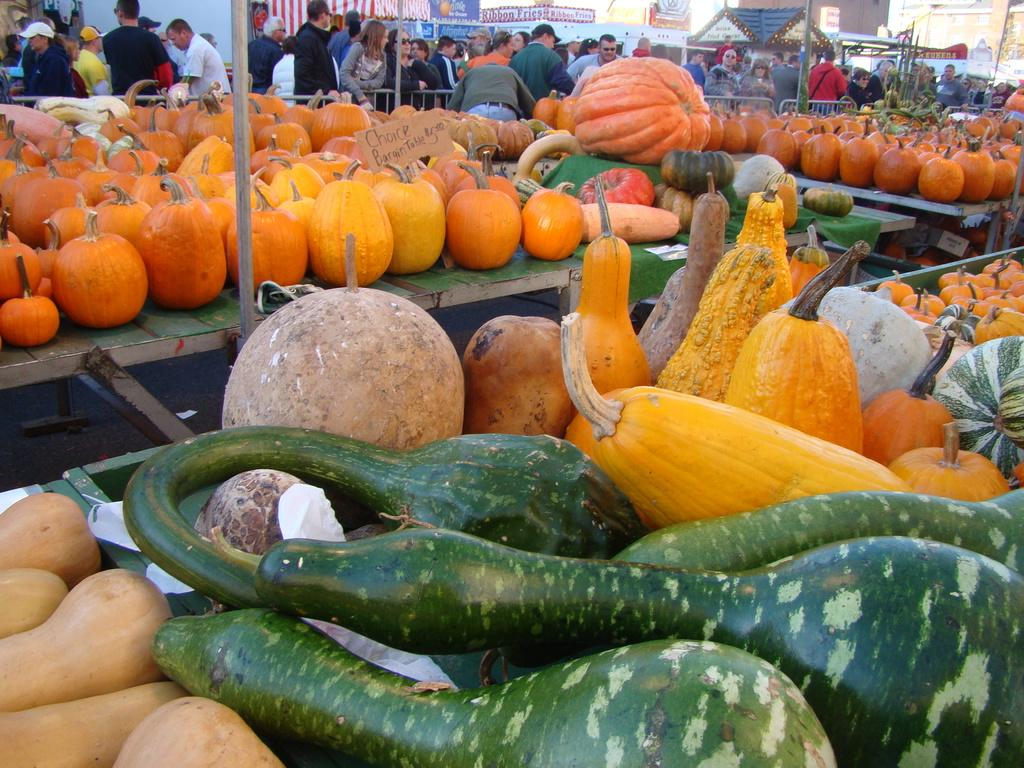What type of food is present on the table in the image? There are vegetables on the table in the image. Can you describe the appearance of the vegetables? The vegetables are in different colors. Who is visible in the image? There is a group of people visible in the image. What is the setting of the image? The image features stores. What type of fruit is being adjusted by the group of people in the image? There is no fruit present in the image, and the group of people is not adjusting anything. 